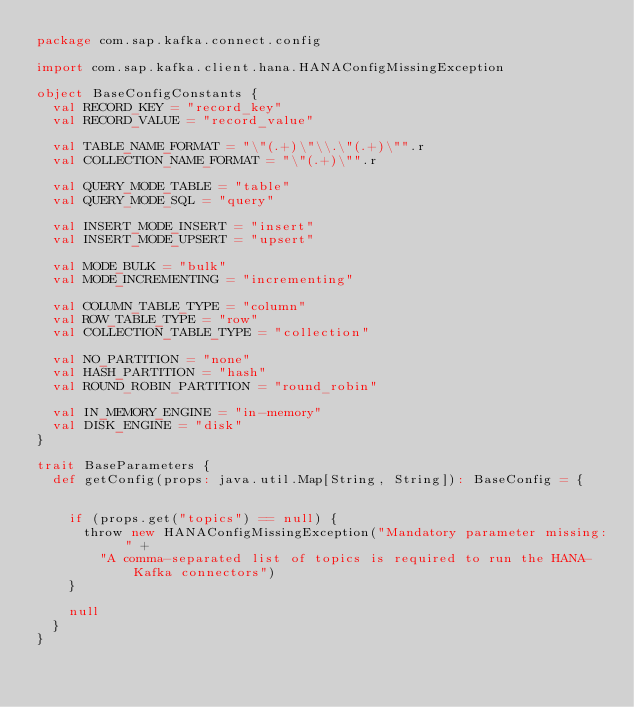Convert code to text. <code><loc_0><loc_0><loc_500><loc_500><_Scala_>package com.sap.kafka.connect.config

import com.sap.kafka.client.hana.HANAConfigMissingException

object BaseConfigConstants {
  val RECORD_KEY = "record_key"
  val RECORD_VALUE = "record_value"

  val TABLE_NAME_FORMAT = "\"(.+)\"\\.\"(.+)\"".r
  val COLLECTION_NAME_FORMAT = "\"(.+)\"".r

  val QUERY_MODE_TABLE = "table"
  val QUERY_MODE_SQL = "query"

  val INSERT_MODE_INSERT = "insert"
  val INSERT_MODE_UPSERT = "upsert"

  val MODE_BULK = "bulk"
  val MODE_INCREMENTING = "incrementing"

  val COLUMN_TABLE_TYPE = "column"
  val ROW_TABLE_TYPE = "row"
  val COLLECTION_TABLE_TYPE = "collection"

  val NO_PARTITION = "none"
  val HASH_PARTITION = "hash"
  val ROUND_ROBIN_PARTITION = "round_robin"

  val IN_MEMORY_ENGINE = "in-memory"
  val DISK_ENGINE = "disk"
}

trait BaseParameters {
  def getConfig(props: java.util.Map[String, String]): BaseConfig = {


    if (props.get("topics") == null) {
      throw new HANAConfigMissingException("Mandatory parameter missing: " +
        "A comma-separated list of topics is required to run the HANA-Kafka connectors")
    }

    null
  }
}
</code> 